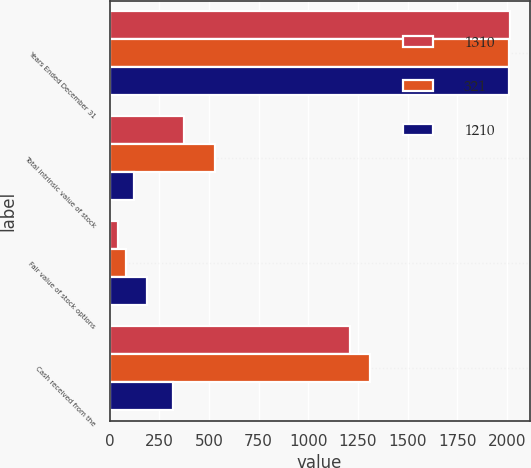<chart> <loc_0><loc_0><loc_500><loc_500><stacked_bar_chart><ecel><fcel>Years Ended December 31<fcel>Total intrinsic value of stock<fcel>Fair value of stock options<fcel>Cash received from the<nl><fcel>1310<fcel>2013<fcel>374<fcel>42<fcel>1210<nl><fcel>321<fcel>2012<fcel>528<fcel>80<fcel>1310<nl><fcel>1210<fcel>2011<fcel>125<fcel>189<fcel>321<nl></chart> 